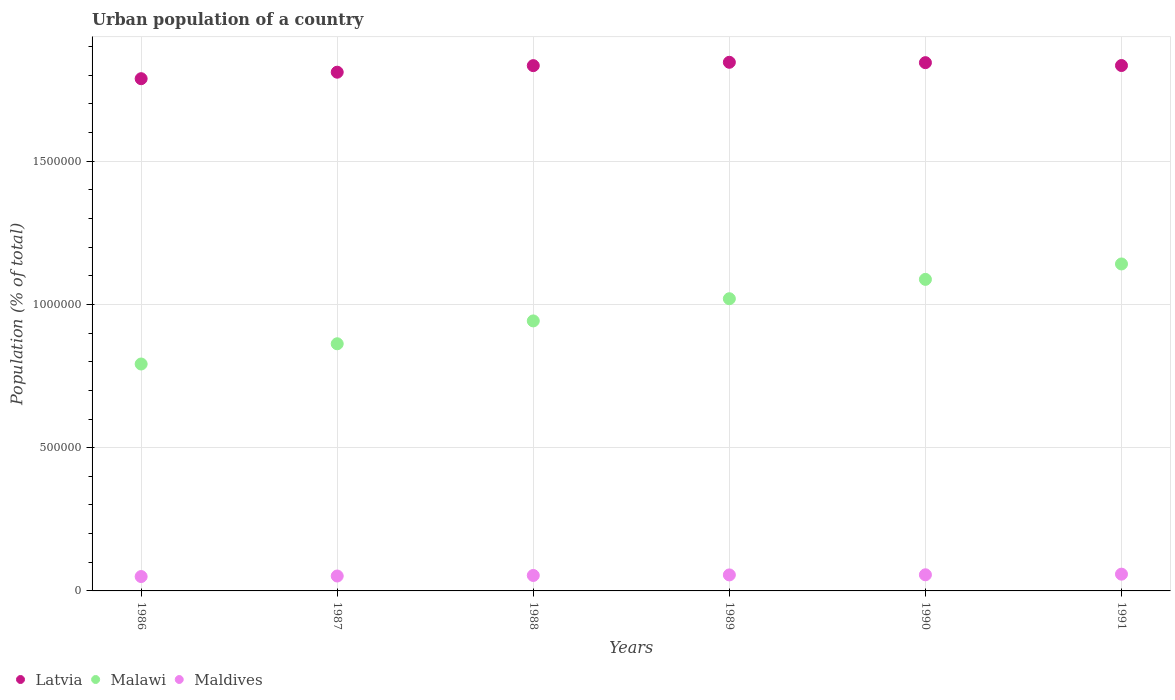What is the urban population in Latvia in 1987?
Give a very brief answer. 1.81e+06. Across all years, what is the maximum urban population in Malawi?
Your answer should be compact. 1.14e+06. Across all years, what is the minimum urban population in Latvia?
Give a very brief answer. 1.79e+06. In which year was the urban population in Maldives minimum?
Your answer should be compact. 1986. What is the total urban population in Maldives in the graph?
Ensure brevity in your answer.  3.27e+05. What is the difference between the urban population in Latvia in 1989 and that in 1991?
Provide a short and direct response. 1.13e+04. What is the difference between the urban population in Malawi in 1990 and the urban population in Latvia in 1987?
Give a very brief answer. -7.23e+05. What is the average urban population in Maldives per year?
Offer a terse response. 5.45e+04. In the year 1987, what is the difference between the urban population in Maldives and urban population in Latvia?
Your answer should be very brief. -1.76e+06. In how many years, is the urban population in Malawi greater than 600000 %?
Provide a short and direct response. 6. What is the ratio of the urban population in Latvia in 1990 to that in 1991?
Provide a succinct answer. 1.01. Is the urban population in Maldives in 1988 less than that in 1990?
Ensure brevity in your answer.  Yes. Is the difference between the urban population in Maldives in 1986 and 1989 greater than the difference between the urban population in Latvia in 1986 and 1989?
Your answer should be compact. Yes. What is the difference between the highest and the second highest urban population in Malawi?
Keep it short and to the point. 5.38e+04. What is the difference between the highest and the lowest urban population in Maldives?
Your response must be concise. 8322. Is it the case that in every year, the sum of the urban population in Latvia and urban population in Maldives  is greater than the urban population in Malawi?
Make the answer very short. Yes. Does the urban population in Malawi monotonically increase over the years?
Your answer should be very brief. Yes. Is the urban population in Latvia strictly greater than the urban population in Malawi over the years?
Your response must be concise. Yes. Is the urban population in Maldives strictly less than the urban population in Latvia over the years?
Your answer should be very brief. Yes. How many dotlines are there?
Make the answer very short. 3. What is the difference between two consecutive major ticks on the Y-axis?
Give a very brief answer. 5.00e+05. Are the values on the major ticks of Y-axis written in scientific E-notation?
Provide a short and direct response. No. Where does the legend appear in the graph?
Offer a very short reply. Bottom left. What is the title of the graph?
Offer a terse response. Urban population of a country. What is the label or title of the X-axis?
Your answer should be very brief. Years. What is the label or title of the Y-axis?
Provide a succinct answer. Population (% of total). What is the Population (% of total) of Latvia in 1986?
Provide a succinct answer. 1.79e+06. What is the Population (% of total) of Malawi in 1986?
Provide a short and direct response. 7.92e+05. What is the Population (% of total) of Maldives in 1986?
Keep it short and to the point. 5.02e+04. What is the Population (% of total) of Latvia in 1987?
Ensure brevity in your answer.  1.81e+06. What is the Population (% of total) in Malawi in 1987?
Ensure brevity in your answer.  8.63e+05. What is the Population (% of total) in Maldives in 1987?
Provide a short and direct response. 5.21e+04. What is the Population (% of total) of Latvia in 1988?
Your answer should be compact. 1.83e+06. What is the Population (% of total) in Malawi in 1988?
Offer a terse response. 9.43e+05. What is the Population (% of total) in Maldives in 1988?
Your answer should be very brief. 5.40e+04. What is the Population (% of total) in Latvia in 1989?
Ensure brevity in your answer.  1.85e+06. What is the Population (% of total) of Malawi in 1989?
Your response must be concise. 1.02e+06. What is the Population (% of total) in Maldives in 1989?
Your answer should be compact. 5.59e+04. What is the Population (% of total) in Latvia in 1990?
Provide a short and direct response. 1.84e+06. What is the Population (% of total) in Malawi in 1990?
Ensure brevity in your answer.  1.09e+06. What is the Population (% of total) in Maldives in 1990?
Your answer should be very brief. 5.63e+04. What is the Population (% of total) of Latvia in 1991?
Ensure brevity in your answer.  1.83e+06. What is the Population (% of total) in Malawi in 1991?
Provide a succinct answer. 1.14e+06. What is the Population (% of total) of Maldives in 1991?
Offer a very short reply. 5.85e+04. Across all years, what is the maximum Population (% of total) in Latvia?
Ensure brevity in your answer.  1.85e+06. Across all years, what is the maximum Population (% of total) in Malawi?
Your answer should be very brief. 1.14e+06. Across all years, what is the maximum Population (% of total) in Maldives?
Your answer should be very brief. 5.85e+04. Across all years, what is the minimum Population (% of total) of Latvia?
Your answer should be compact. 1.79e+06. Across all years, what is the minimum Population (% of total) in Malawi?
Ensure brevity in your answer.  7.92e+05. Across all years, what is the minimum Population (% of total) in Maldives?
Your response must be concise. 5.02e+04. What is the total Population (% of total) in Latvia in the graph?
Provide a short and direct response. 1.10e+07. What is the total Population (% of total) of Malawi in the graph?
Your answer should be compact. 5.85e+06. What is the total Population (% of total) of Maldives in the graph?
Make the answer very short. 3.27e+05. What is the difference between the Population (% of total) of Latvia in 1986 and that in 1987?
Your answer should be compact. -2.27e+04. What is the difference between the Population (% of total) in Malawi in 1986 and that in 1987?
Provide a short and direct response. -7.06e+04. What is the difference between the Population (% of total) of Maldives in 1986 and that in 1987?
Keep it short and to the point. -1891. What is the difference between the Population (% of total) of Latvia in 1986 and that in 1988?
Provide a succinct answer. -4.56e+04. What is the difference between the Population (% of total) of Malawi in 1986 and that in 1988?
Your answer should be very brief. -1.50e+05. What is the difference between the Population (% of total) in Maldives in 1986 and that in 1988?
Your response must be concise. -3793. What is the difference between the Population (% of total) in Latvia in 1986 and that in 1989?
Offer a terse response. -5.73e+04. What is the difference between the Population (% of total) of Malawi in 1986 and that in 1989?
Give a very brief answer. -2.28e+05. What is the difference between the Population (% of total) of Maldives in 1986 and that in 1989?
Make the answer very short. -5694. What is the difference between the Population (% of total) of Latvia in 1986 and that in 1990?
Give a very brief answer. -5.60e+04. What is the difference between the Population (% of total) in Malawi in 1986 and that in 1990?
Provide a succinct answer. -2.95e+05. What is the difference between the Population (% of total) of Maldives in 1986 and that in 1990?
Your answer should be very brief. -6141. What is the difference between the Population (% of total) of Latvia in 1986 and that in 1991?
Your answer should be very brief. -4.60e+04. What is the difference between the Population (% of total) in Malawi in 1986 and that in 1991?
Your answer should be very brief. -3.49e+05. What is the difference between the Population (% of total) of Maldives in 1986 and that in 1991?
Offer a terse response. -8322. What is the difference between the Population (% of total) in Latvia in 1987 and that in 1988?
Offer a very short reply. -2.29e+04. What is the difference between the Population (% of total) of Malawi in 1987 and that in 1988?
Offer a terse response. -7.98e+04. What is the difference between the Population (% of total) in Maldives in 1987 and that in 1988?
Offer a terse response. -1902. What is the difference between the Population (% of total) in Latvia in 1987 and that in 1989?
Provide a succinct answer. -3.46e+04. What is the difference between the Population (% of total) in Malawi in 1987 and that in 1989?
Ensure brevity in your answer.  -1.57e+05. What is the difference between the Population (% of total) of Maldives in 1987 and that in 1989?
Give a very brief answer. -3803. What is the difference between the Population (% of total) in Latvia in 1987 and that in 1990?
Give a very brief answer. -3.33e+04. What is the difference between the Population (% of total) in Malawi in 1987 and that in 1990?
Give a very brief answer. -2.25e+05. What is the difference between the Population (% of total) in Maldives in 1987 and that in 1990?
Give a very brief answer. -4250. What is the difference between the Population (% of total) in Latvia in 1987 and that in 1991?
Your response must be concise. -2.33e+04. What is the difference between the Population (% of total) in Malawi in 1987 and that in 1991?
Provide a short and direct response. -2.79e+05. What is the difference between the Population (% of total) of Maldives in 1987 and that in 1991?
Offer a very short reply. -6431. What is the difference between the Population (% of total) of Latvia in 1988 and that in 1989?
Provide a succinct answer. -1.17e+04. What is the difference between the Population (% of total) of Malawi in 1988 and that in 1989?
Keep it short and to the point. -7.75e+04. What is the difference between the Population (% of total) of Maldives in 1988 and that in 1989?
Offer a terse response. -1901. What is the difference between the Population (% of total) in Latvia in 1988 and that in 1990?
Offer a very short reply. -1.04e+04. What is the difference between the Population (% of total) of Malawi in 1988 and that in 1990?
Make the answer very short. -1.45e+05. What is the difference between the Population (% of total) of Maldives in 1988 and that in 1990?
Provide a succinct answer. -2348. What is the difference between the Population (% of total) of Latvia in 1988 and that in 1991?
Give a very brief answer. -388. What is the difference between the Population (% of total) in Malawi in 1988 and that in 1991?
Your answer should be compact. -1.99e+05. What is the difference between the Population (% of total) of Maldives in 1988 and that in 1991?
Your answer should be very brief. -4529. What is the difference between the Population (% of total) in Latvia in 1989 and that in 1990?
Your answer should be very brief. 1301. What is the difference between the Population (% of total) in Malawi in 1989 and that in 1990?
Give a very brief answer. -6.76e+04. What is the difference between the Population (% of total) in Maldives in 1989 and that in 1990?
Your answer should be very brief. -447. What is the difference between the Population (% of total) of Latvia in 1989 and that in 1991?
Your response must be concise. 1.13e+04. What is the difference between the Population (% of total) in Malawi in 1989 and that in 1991?
Keep it short and to the point. -1.21e+05. What is the difference between the Population (% of total) of Maldives in 1989 and that in 1991?
Your answer should be very brief. -2628. What is the difference between the Population (% of total) in Latvia in 1990 and that in 1991?
Offer a very short reply. 1.00e+04. What is the difference between the Population (% of total) in Malawi in 1990 and that in 1991?
Make the answer very short. -5.38e+04. What is the difference between the Population (% of total) of Maldives in 1990 and that in 1991?
Offer a terse response. -2181. What is the difference between the Population (% of total) of Latvia in 1986 and the Population (% of total) of Malawi in 1987?
Your answer should be very brief. 9.25e+05. What is the difference between the Population (% of total) in Latvia in 1986 and the Population (% of total) in Maldives in 1987?
Provide a succinct answer. 1.74e+06. What is the difference between the Population (% of total) of Malawi in 1986 and the Population (% of total) of Maldives in 1987?
Give a very brief answer. 7.40e+05. What is the difference between the Population (% of total) in Latvia in 1986 and the Population (% of total) in Malawi in 1988?
Offer a very short reply. 8.46e+05. What is the difference between the Population (% of total) in Latvia in 1986 and the Population (% of total) in Maldives in 1988?
Your answer should be compact. 1.73e+06. What is the difference between the Population (% of total) of Malawi in 1986 and the Population (% of total) of Maldives in 1988?
Make the answer very short. 7.38e+05. What is the difference between the Population (% of total) of Latvia in 1986 and the Population (% of total) of Malawi in 1989?
Provide a succinct answer. 7.68e+05. What is the difference between the Population (% of total) in Latvia in 1986 and the Population (% of total) in Maldives in 1989?
Make the answer very short. 1.73e+06. What is the difference between the Population (% of total) in Malawi in 1986 and the Population (% of total) in Maldives in 1989?
Your response must be concise. 7.36e+05. What is the difference between the Population (% of total) in Latvia in 1986 and the Population (% of total) in Malawi in 1990?
Keep it short and to the point. 7.01e+05. What is the difference between the Population (% of total) of Latvia in 1986 and the Population (% of total) of Maldives in 1990?
Ensure brevity in your answer.  1.73e+06. What is the difference between the Population (% of total) of Malawi in 1986 and the Population (% of total) of Maldives in 1990?
Offer a very short reply. 7.36e+05. What is the difference between the Population (% of total) in Latvia in 1986 and the Population (% of total) in Malawi in 1991?
Keep it short and to the point. 6.47e+05. What is the difference between the Population (% of total) in Latvia in 1986 and the Population (% of total) in Maldives in 1991?
Your answer should be compact. 1.73e+06. What is the difference between the Population (% of total) in Malawi in 1986 and the Population (% of total) in Maldives in 1991?
Give a very brief answer. 7.34e+05. What is the difference between the Population (% of total) of Latvia in 1987 and the Population (% of total) of Malawi in 1988?
Provide a succinct answer. 8.68e+05. What is the difference between the Population (% of total) of Latvia in 1987 and the Population (% of total) of Maldives in 1988?
Offer a very short reply. 1.76e+06. What is the difference between the Population (% of total) of Malawi in 1987 and the Population (% of total) of Maldives in 1988?
Your response must be concise. 8.09e+05. What is the difference between the Population (% of total) in Latvia in 1987 and the Population (% of total) in Malawi in 1989?
Keep it short and to the point. 7.91e+05. What is the difference between the Population (% of total) in Latvia in 1987 and the Population (% of total) in Maldives in 1989?
Your answer should be compact. 1.76e+06. What is the difference between the Population (% of total) of Malawi in 1987 and the Population (% of total) of Maldives in 1989?
Provide a succinct answer. 8.07e+05. What is the difference between the Population (% of total) of Latvia in 1987 and the Population (% of total) of Malawi in 1990?
Your answer should be very brief. 7.23e+05. What is the difference between the Population (% of total) in Latvia in 1987 and the Population (% of total) in Maldives in 1990?
Provide a short and direct response. 1.75e+06. What is the difference between the Population (% of total) of Malawi in 1987 and the Population (% of total) of Maldives in 1990?
Give a very brief answer. 8.06e+05. What is the difference between the Population (% of total) of Latvia in 1987 and the Population (% of total) of Malawi in 1991?
Offer a terse response. 6.69e+05. What is the difference between the Population (% of total) in Latvia in 1987 and the Population (% of total) in Maldives in 1991?
Ensure brevity in your answer.  1.75e+06. What is the difference between the Population (% of total) of Malawi in 1987 and the Population (% of total) of Maldives in 1991?
Ensure brevity in your answer.  8.04e+05. What is the difference between the Population (% of total) of Latvia in 1988 and the Population (% of total) of Malawi in 1989?
Your answer should be very brief. 8.14e+05. What is the difference between the Population (% of total) of Latvia in 1988 and the Population (% of total) of Maldives in 1989?
Your response must be concise. 1.78e+06. What is the difference between the Population (% of total) of Malawi in 1988 and the Population (% of total) of Maldives in 1989?
Ensure brevity in your answer.  8.87e+05. What is the difference between the Population (% of total) in Latvia in 1988 and the Population (% of total) in Malawi in 1990?
Provide a short and direct response. 7.46e+05. What is the difference between the Population (% of total) in Latvia in 1988 and the Population (% of total) in Maldives in 1990?
Your response must be concise. 1.78e+06. What is the difference between the Population (% of total) in Malawi in 1988 and the Population (% of total) in Maldives in 1990?
Give a very brief answer. 8.86e+05. What is the difference between the Population (% of total) of Latvia in 1988 and the Population (% of total) of Malawi in 1991?
Ensure brevity in your answer.  6.92e+05. What is the difference between the Population (% of total) in Latvia in 1988 and the Population (% of total) in Maldives in 1991?
Give a very brief answer. 1.78e+06. What is the difference between the Population (% of total) of Malawi in 1988 and the Population (% of total) of Maldives in 1991?
Ensure brevity in your answer.  8.84e+05. What is the difference between the Population (% of total) in Latvia in 1989 and the Population (% of total) in Malawi in 1990?
Keep it short and to the point. 7.58e+05. What is the difference between the Population (% of total) in Latvia in 1989 and the Population (% of total) in Maldives in 1990?
Your answer should be compact. 1.79e+06. What is the difference between the Population (% of total) in Malawi in 1989 and the Population (% of total) in Maldives in 1990?
Your answer should be compact. 9.64e+05. What is the difference between the Population (% of total) in Latvia in 1989 and the Population (% of total) in Malawi in 1991?
Your answer should be very brief. 7.04e+05. What is the difference between the Population (% of total) in Latvia in 1989 and the Population (% of total) in Maldives in 1991?
Your response must be concise. 1.79e+06. What is the difference between the Population (% of total) of Malawi in 1989 and the Population (% of total) of Maldives in 1991?
Make the answer very short. 9.62e+05. What is the difference between the Population (% of total) in Latvia in 1990 and the Population (% of total) in Malawi in 1991?
Make the answer very short. 7.03e+05. What is the difference between the Population (% of total) in Latvia in 1990 and the Population (% of total) in Maldives in 1991?
Provide a succinct answer. 1.79e+06. What is the difference between the Population (% of total) in Malawi in 1990 and the Population (% of total) in Maldives in 1991?
Offer a very short reply. 1.03e+06. What is the average Population (% of total) in Latvia per year?
Ensure brevity in your answer.  1.83e+06. What is the average Population (% of total) of Malawi per year?
Your response must be concise. 9.74e+05. What is the average Population (% of total) in Maldives per year?
Your response must be concise. 5.45e+04. In the year 1986, what is the difference between the Population (% of total) in Latvia and Population (% of total) in Malawi?
Your response must be concise. 9.96e+05. In the year 1986, what is the difference between the Population (% of total) in Latvia and Population (% of total) in Maldives?
Your answer should be very brief. 1.74e+06. In the year 1986, what is the difference between the Population (% of total) of Malawi and Population (% of total) of Maldives?
Offer a terse response. 7.42e+05. In the year 1987, what is the difference between the Population (% of total) of Latvia and Population (% of total) of Malawi?
Your answer should be compact. 9.48e+05. In the year 1987, what is the difference between the Population (% of total) in Latvia and Population (% of total) in Maldives?
Your answer should be very brief. 1.76e+06. In the year 1987, what is the difference between the Population (% of total) of Malawi and Population (% of total) of Maldives?
Your answer should be very brief. 8.11e+05. In the year 1988, what is the difference between the Population (% of total) of Latvia and Population (% of total) of Malawi?
Keep it short and to the point. 8.91e+05. In the year 1988, what is the difference between the Population (% of total) in Latvia and Population (% of total) in Maldives?
Your answer should be very brief. 1.78e+06. In the year 1988, what is the difference between the Population (% of total) of Malawi and Population (% of total) of Maldives?
Provide a succinct answer. 8.89e+05. In the year 1989, what is the difference between the Population (% of total) of Latvia and Population (% of total) of Malawi?
Your answer should be compact. 8.25e+05. In the year 1989, what is the difference between the Population (% of total) in Latvia and Population (% of total) in Maldives?
Provide a short and direct response. 1.79e+06. In the year 1989, what is the difference between the Population (% of total) of Malawi and Population (% of total) of Maldives?
Your answer should be compact. 9.64e+05. In the year 1990, what is the difference between the Population (% of total) in Latvia and Population (% of total) in Malawi?
Make the answer very short. 7.57e+05. In the year 1990, what is the difference between the Population (% of total) of Latvia and Population (% of total) of Maldives?
Your answer should be compact. 1.79e+06. In the year 1990, what is the difference between the Population (% of total) in Malawi and Population (% of total) in Maldives?
Give a very brief answer. 1.03e+06. In the year 1991, what is the difference between the Population (% of total) in Latvia and Population (% of total) in Malawi?
Offer a very short reply. 6.93e+05. In the year 1991, what is the difference between the Population (% of total) of Latvia and Population (% of total) of Maldives?
Offer a terse response. 1.78e+06. In the year 1991, what is the difference between the Population (% of total) in Malawi and Population (% of total) in Maldives?
Make the answer very short. 1.08e+06. What is the ratio of the Population (% of total) in Latvia in 1986 to that in 1987?
Provide a short and direct response. 0.99. What is the ratio of the Population (% of total) of Malawi in 1986 to that in 1987?
Make the answer very short. 0.92. What is the ratio of the Population (% of total) in Maldives in 1986 to that in 1987?
Offer a terse response. 0.96. What is the ratio of the Population (% of total) of Latvia in 1986 to that in 1988?
Make the answer very short. 0.98. What is the ratio of the Population (% of total) in Malawi in 1986 to that in 1988?
Your answer should be compact. 0.84. What is the ratio of the Population (% of total) in Maldives in 1986 to that in 1988?
Ensure brevity in your answer.  0.93. What is the ratio of the Population (% of total) of Latvia in 1986 to that in 1989?
Provide a short and direct response. 0.97. What is the ratio of the Population (% of total) of Malawi in 1986 to that in 1989?
Your response must be concise. 0.78. What is the ratio of the Population (% of total) of Maldives in 1986 to that in 1989?
Make the answer very short. 0.9. What is the ratio of the Population (% of total) in Latvia in 1986 to that in 1990?
Your answer should be very brief. 0.97. What is the ratio of the Population (% of total) of Malawi in 1986 to that in 1990?
Provide a succinct answer. 0.73. What is the ratio of the Population (% of total) in Maldives in 1986 to that in 1990?
Ensure brevity in your answer.  0.89. What is the ratio of the Population (% of total) of Latvia in 1986 to that in 1991?
Provide a short and direct response. 0.97. What is the ratio of the Population (% of total) in Malawi in 1986 to that in 1991?
Your answer should be very brief. 0.69. What is the ratio of the Population (% of total) in Maldives in 1986 to that in 1991?
Your response must be concise. 0.86. What is the ratio of the Population (% of total) of Latvia in 1987 to that in 1988?
Your answer should be compact. 0.99. What is the ratio of the Population (% of total) in Malawi in 1987 to that in 1988?
Offer a very short reply. 0.92. What is the ratio of the Population (% of total) of Maldives in 1987 to that in 1988?
Your answer should be very brief. 0.96. What is the ratio of the Population (% of total) in Latvia in 1987 to that in 1989?
Keep it short and to the point. 0.98. What is the ratio of the Population (% of total) in Malawi in 1987 to that in 1989?
Keep it short and to the point. 0.85. What is the ratio of the Population (% of total) in Maldives in 1987 to that in 1989?
Your response must be concise. 0.93. What is the ratio of the Population (% of total) of Malawi in 1987 to that in 1990?
Keep it short and to the point. 0.79. What is the ratio of the Population (% of total) in Maldives in 1987 to that in 1990?
Your response must be concise. 0.92. What is the ratio of the Population (% of total) of Latvia in 1987 to that in 1991?
Ensure brevity in your answer.  0.99. What is the ratio of the Population (% of total) of Malawi in 1987 to that in 1991?
Your response must be concise. 0.76. What is the ratio of the Population (% of total) of Maldives in 1987 to that in 1991?
Give a very brief answer. 0.89. What is the ratio of the Population (% of total) in Malawi in 1988 to that in 1989?
Give a very brief answer. 0.92. What is the ratio of the Population (% of total) of Maldives in 1988 to that in 1989?
Ensure brevity in your answer.  0.97. What is the ratio of the Population (% of total) in Malawi in 1988 to that in 1990?
Your response must be concise. 0.87. What is the ratio of the Population (% of total) of Maldives in 1988 to that in 1990?
Provide a short and direct response. 0.96. What is the ratio of the Population (% of total) of Latvia in 1988 to that in 1991?
Your answer should be very brief. 1. What is the ratio of the Population (% of total) of Malawi in 1988 to that in 1991?
Your answer should be compact. 0.83. What is the ratio of the Population (% of total) in Maldives in 1988 to that in 1991?
Provide a short and direct response. 0.92. What is the ratio of the Population (% of total) in Latvia in 1989 to that in 1990?
Make the answer very short. 1. What is the ratio of the Population (% of total) of Malawi in 1989 to that in 1990?
Ensure brevity in your answer.  0.94. What is the ratio of the Population (% of total) of Latvia in 1989 to that in 1991?
Your answer should be very brief. 1.01. What is the ratio of the Population (% of total) of Malawi in 1989 to that in 1991?
Offer a very short reply. 0.89. What is the ratio of the Population (% of total) of Maldives in 1989 to that in 1991?
Offer a very short reply. 0.96. What is the ratio of the Population (% of total) in Malawi in 1990 to that in 1991?
Your answer should be very brief. 0.95. What is the ratio of the Population (% of total) in Maldives in 1990 to that in 1991?
Give a very brief answer. 0.96. What is the difference between the highest and the second highest Population (% of total) in Latvia?
Provide a succinct answer. 1301. What is the difference between the highest and the second highest Population (% of total) in Malawi?
Offer a very short reply. 5.38e+04. What is the difference between the highest and the second highest Population (% of total) of Maldives?
Make the answer very short. 2181. What is the difference between the highest and the lowest Population (% of total) of Latvia?
Keep it short and to the point. 5.73e+04. What is the difference between the highest and the lowest Population (% of total) of Malawi?
Offer a terse response. 3.49e+05. What is the difference between the highest and the lowest Population (% of total) in Maldives?
Your answer should be compact. 8322. 